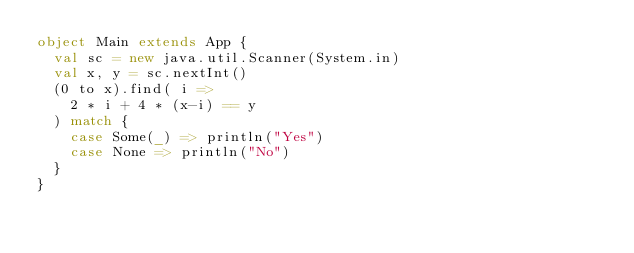Convert code to text. <code><loc_0><loc_0><loc_500><loc_500><_Scala_>object Main extends App {
  val sc = new java.util.Scanner(System.in)
  val x, y = sc.nextInt()
  (0 to x).find( i =>
    2 * i + 4 * (x-i) == y
  ) match {
    case Some(_) => println("Yes")
    case None => println("No")
  }
}
</code> 